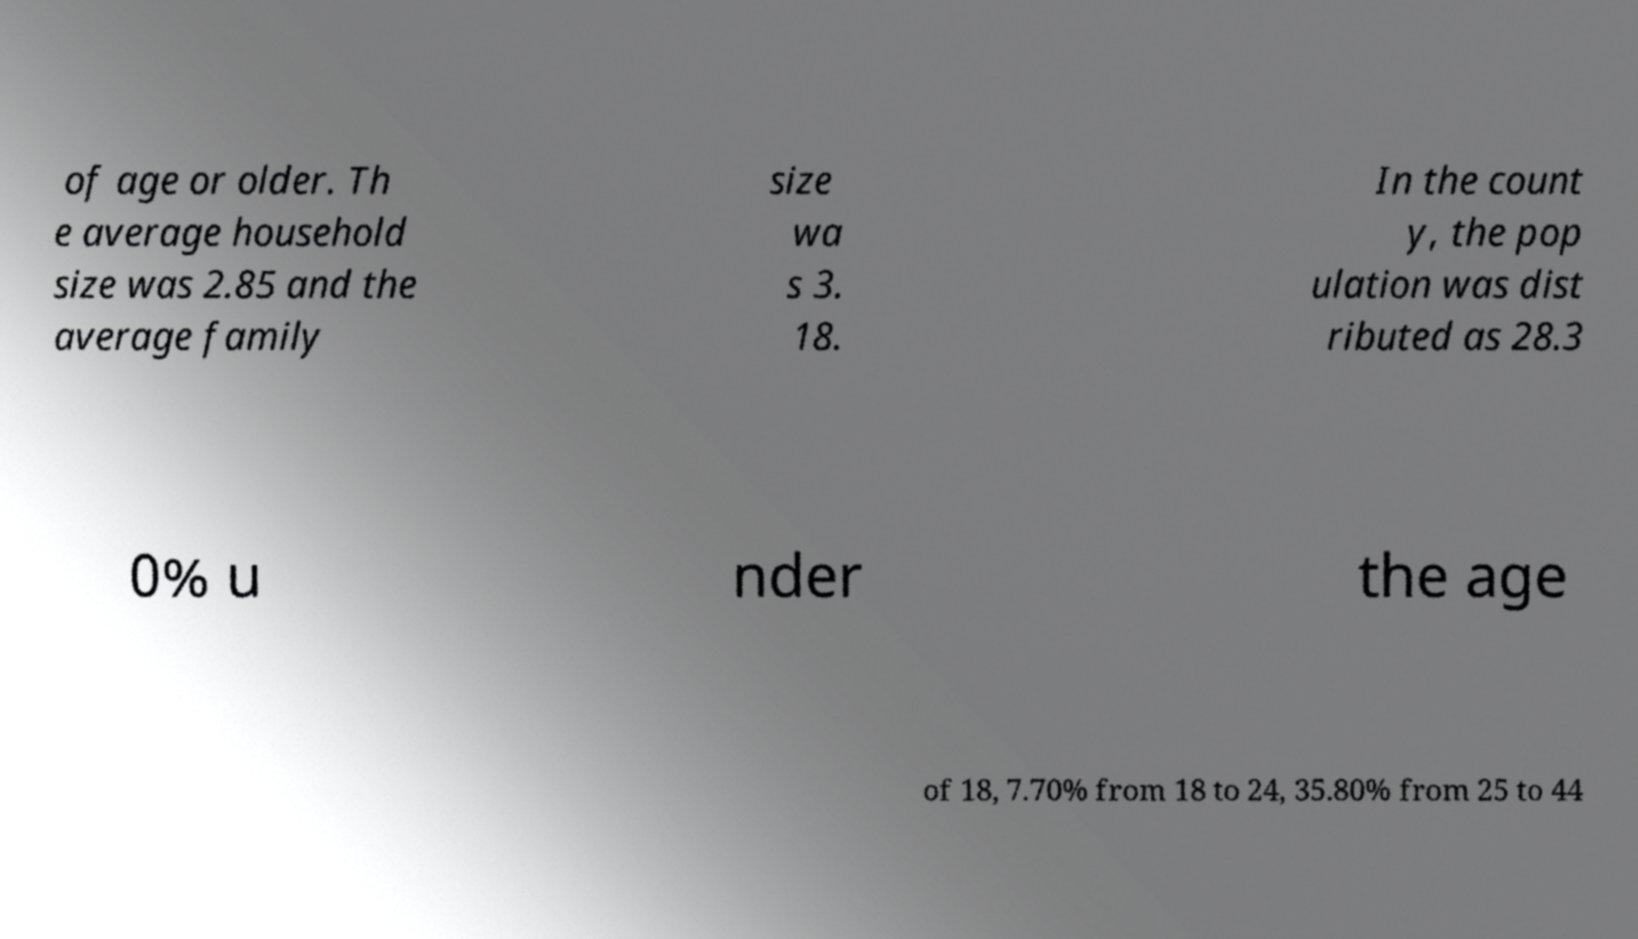Can you accurately transcribe the text from the provided image for me? of age or older. Th e average household size was 2.85 and the average family size wa s 3. 18. In the count y, the pop ulation was dist ributed as 28.3 0% u nder the age of 18, 7.70% from 18 to 24, 35.80% from 25 to 44 